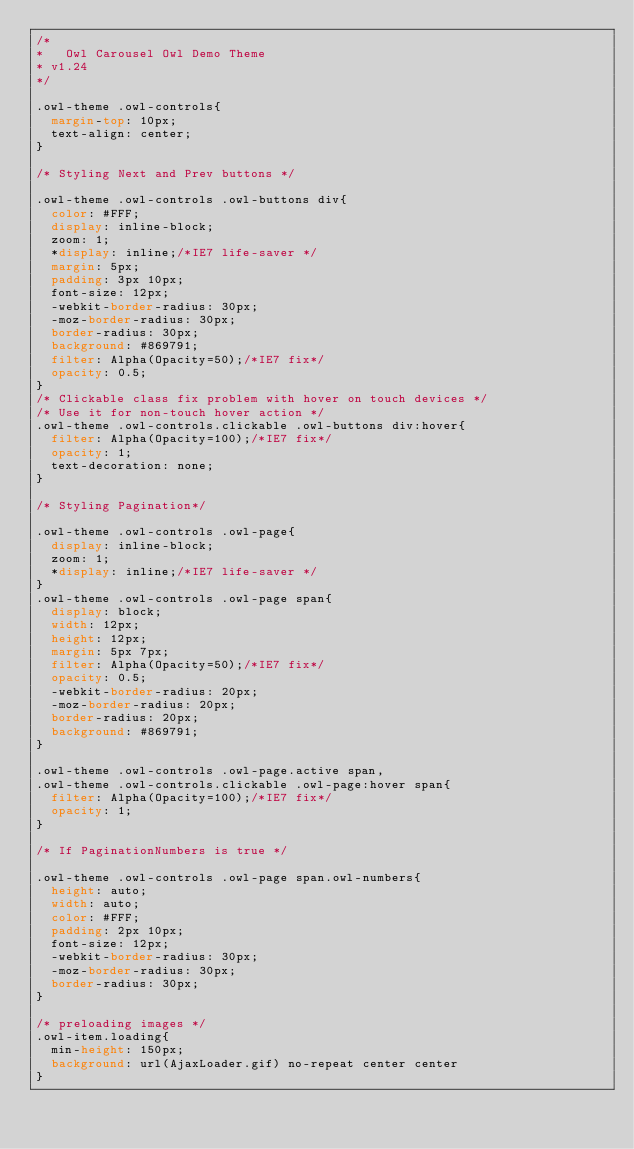<code> <loc_0><loc_0><loc_500><loc_500><_CSS_>/*
* 	Owl Carousel Owl Demo Theme 
*	v1.24
*/

.owl-theme .owl-controls{
	margin-top: 10px;
	text-align: center;
}

/* Styling Next and Prev buttons */

.owl-theme .owl-controls .owl-buttons div{
	color: #FFF;
	display: inline-block;
	zoom: 1;
	*display: inline;/*IE7 life-saver */
	margin: 5px;
	padding: 3px 10px;
	font-size: 12px;
	-webkit-border-radius: 30px;
	-moz-border-radius: 30px;
	border-radius: 30px;
	background: #869791;
	filter: Alpha(Opacity=50);/*IE7 fix*/
	opacity: 0.5;
}
/* Clickable class fix problem with hover on touch devices */
/* Use it for non-touch hover action */
.owl-theme .owl-controls.clickable .owl-buttons div:hover{
	filter: Alpha(Opacity=100);/*IE7 fix*/
	opacity: 1;
	text-decoration: none;
}

/* Styling Pagination*/

.owl-theme .owl-controls .owl-page{
	display: inline-block;
	zoom: 1;
	*display: inline;/*IE7 life-saver */
}
.owl-theme .owl-controls .owl-page span{
	display: block;
	width: 12px;
	height: 12px;
	margin: 5px 7px;
	filter: Alpha(Opacity=50);/*IE7 fix*/
	opacity: 0.5;
	-webkit-border-radius: 20px;
	-moz-border-radius: 20px;
	border-radius: 20px;
	background: #869791;
}

.owl-theme .owl-controls .owl-page.active span,
.owl-theme .owl-controls.clickable .owl-page:hover span{
	filter: Alpha(Opacity=100);/*IE7 fix*/
	opacity: 1;
}

/* If PaginationNumbers is true */

.owl-theme .owl-controls .owl-page span.owl-numbers{
	height: auto;
	width: auto;
	color: #FFF;
	padding: 2px 10px;
	font-size: 12px;
	-webkit-border-radius: 30px;
	-moz-border-radius: 30px;
	border-radius: 30px;
}

/* preloading images */
.owl-item.loading{
	min-height: 150px;
	background: url(AjaxLoader.gif) no-repeat center center
}

</code> 